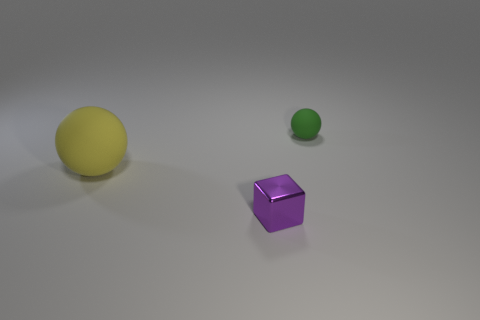Add 2 small yellow blocks. How many objects exist? 5 Subtract all blocks. How many objects are left? 2 Add 1 metallic objects. How many metallic objects are left? 2 Add 3 rubber things. How many rubber things exist? 5 Subtract 0 brown balls. How many objects are left? 3 Subtract all large matte balls. Subtract all small matte things. How many objects are left? 1 